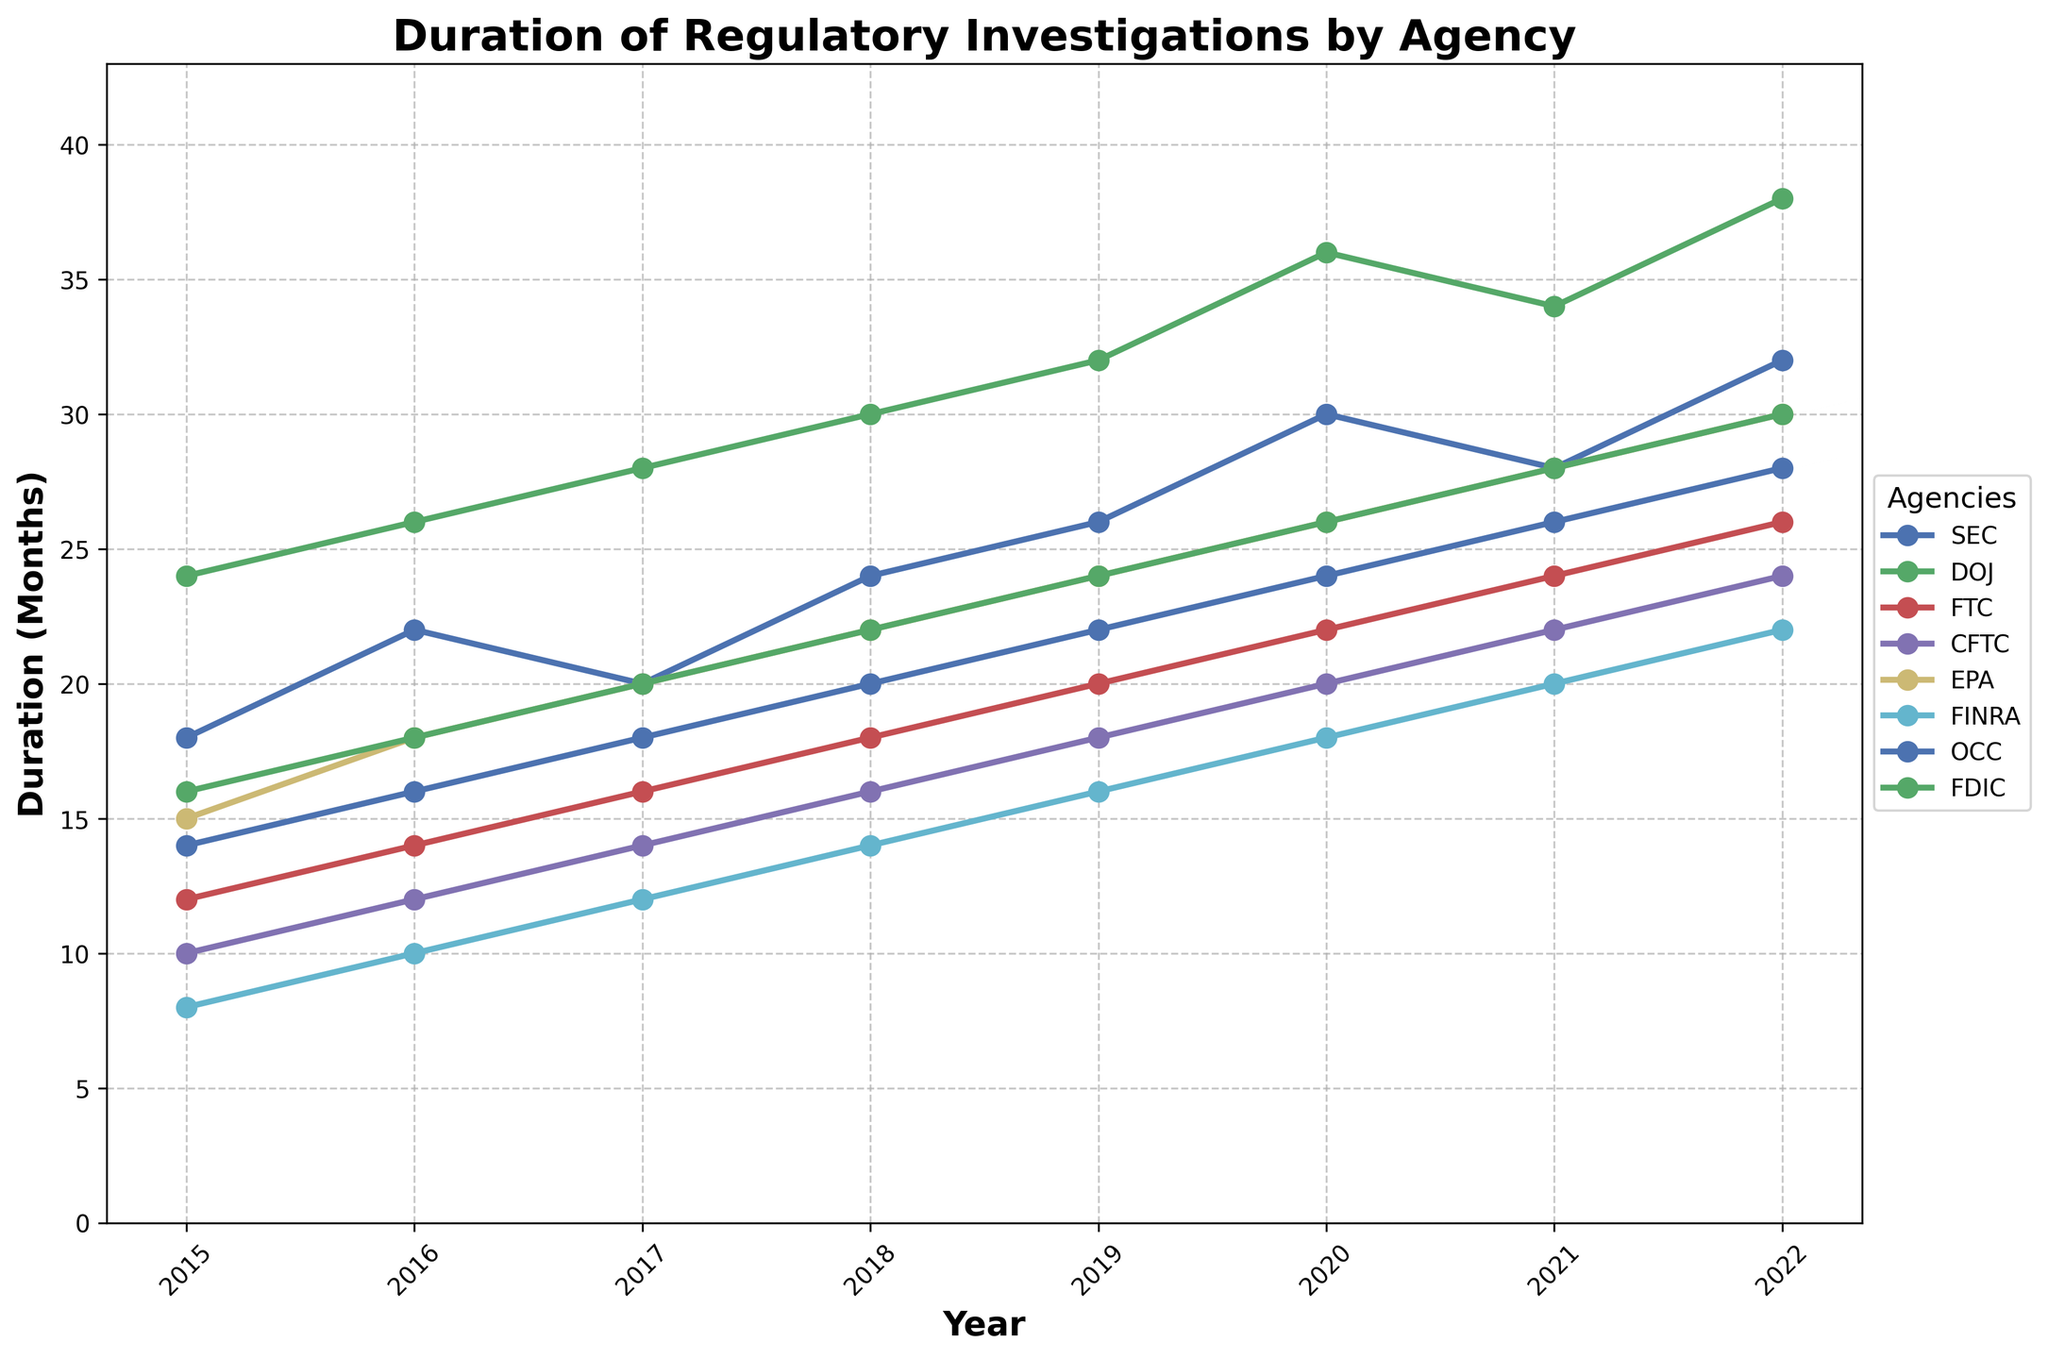What is the average duration of regulatory investigations conducted by the SEC between 2015 and 2022? To find the average duration of regulatory investigations conducted by the SEC between 2015 and 2022, add the values from 2015 to 2022 and divide by the number of years (8): (18 + 22 + 20 + 24 + 26 + 30 + 28 + 32) / 8 = 200 / 8 = 25 months
Answer: 25 months Which agency had the longest duration of regulatory investigations in 2022? To find the agency with the longest duration of investigations in 2022, compare the values for each agency in 2022: SEC (32), DOJ (38), FTC (26), CFTC (24), EPA (30), FINRA (22), OCC (28), FDIC (30). The DOJ had the longest duration with 38 months.
Answer: DOJ How many agencies experienced an increase in the duration of their investigations every year from 2015 to 2022? To determine how many agencies experienced a year-over-year increase in the duration of their investigations from 2015 to 2022, examine the trend for each agency. Not all agencies show a constant increase: SEC (not constant), DOJ (constant), FTC (constant), CFTC (constant), EPA (constant), FINRA (constant), OCC (constant), FDIC (constant). There are 7 agencies with consistent increases.
Answer: 7 Between 2016 and 2019, which agency had the greatest increase in the duration of investigations? Calculate the increase for each agency from 2016 to 2019: SEC (26 - 22 = 4), DOJ (32 - 26 = 6), FTC (20 - 14 = 6), CFTC (18 - 12 = 6), EPA (24 - 18 = 6), FINRA (16 - 10 = 6), OCC (22 - 16 = 6), FDIC (24 - 18 = 6). The agencies DOJ, FTC, CFTC, EPA, FINRA, OCC, and FDIC all had the greatest increases of 6 months.
Answer: DOJ, FTC, CFTC, EPA, FINRA, OCC, FDIC What is the overall trend of investigation durations for the EPA from 2015 to 2022? To determine the overall trend, observe the values for EPA from 2015 to 2022: 15, 18, 20, 22, 24, 26, 28, 30. The values are consistently increasing each year.
Answer: Increasing Compare the duration of investigations between the FTC and CFTC in 2020. Which agency had shorter investigations? Look at the data points for FTC and CFTC in 2020: FTC (22), CFTC (20). The CFTC had shorter investigations.
Answer: CFTC What is the total duration of investigations for FINRA from 2017 to 2019? Summing the values for FINRA from 2017 to 2019: 12 + 14 + 16 = 42 months.
Answer: 42 months Which year had the smallest difference between investigation durations of SEC and DOJ? Calculate the differences for each year: 2015 (24-18=6), 2016 (26-22=4), 2017 (28-20=8), 2018 (30-24=6), 2019 (32-26=6), 2020 (36-30=6), 2021 (34-28=6), 2022 (38-32=6). The smallest difference is in 2016, at 4 months.
Answer: 2016 